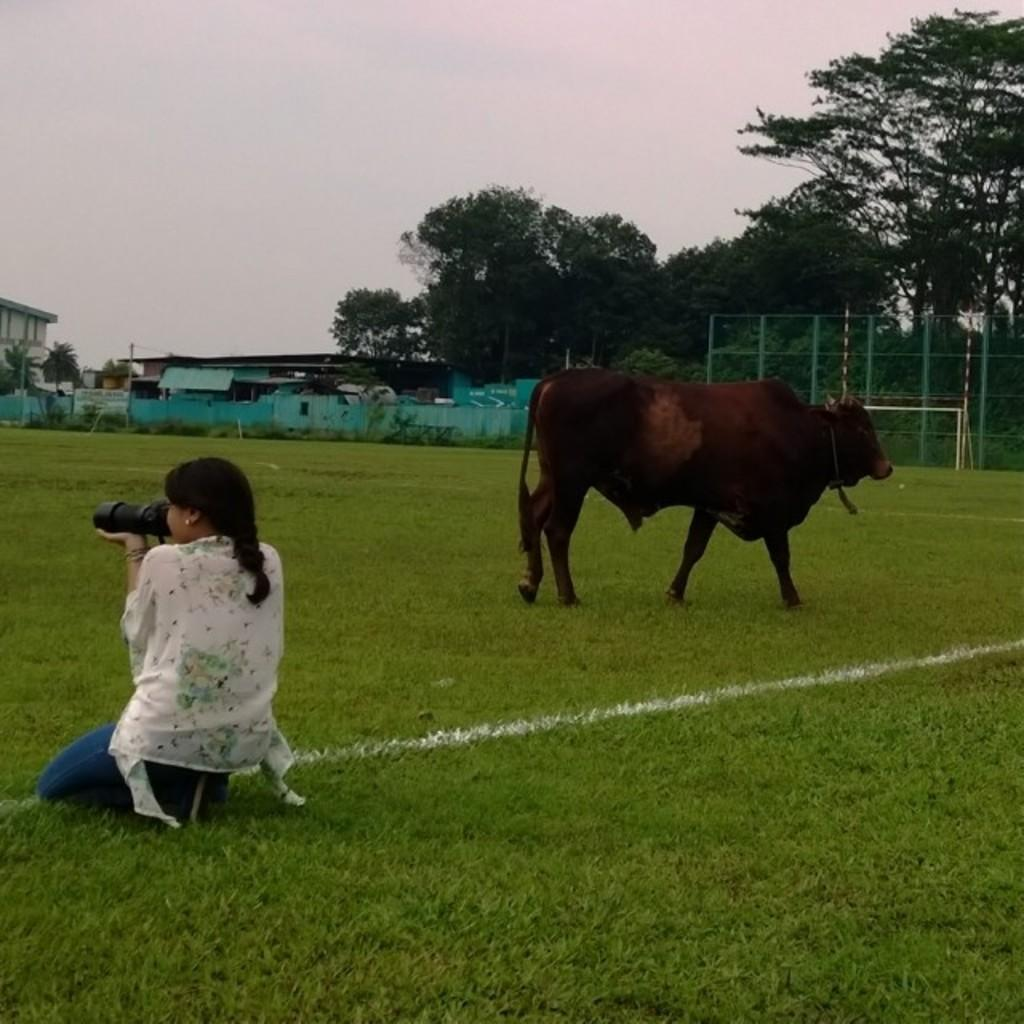What is the person on the left side of the image doing? The person on the left side of the image is taking pictures. What can be seen on the right side of the image? There is an animal walking on the ground on the right side of the image. What is visible in the background of the image? There are trees visible in the background of the image. What type of wood is the skate made of in the image? There is no skate present in the image, so it is not possible to determine what type of wood it might be made of. 